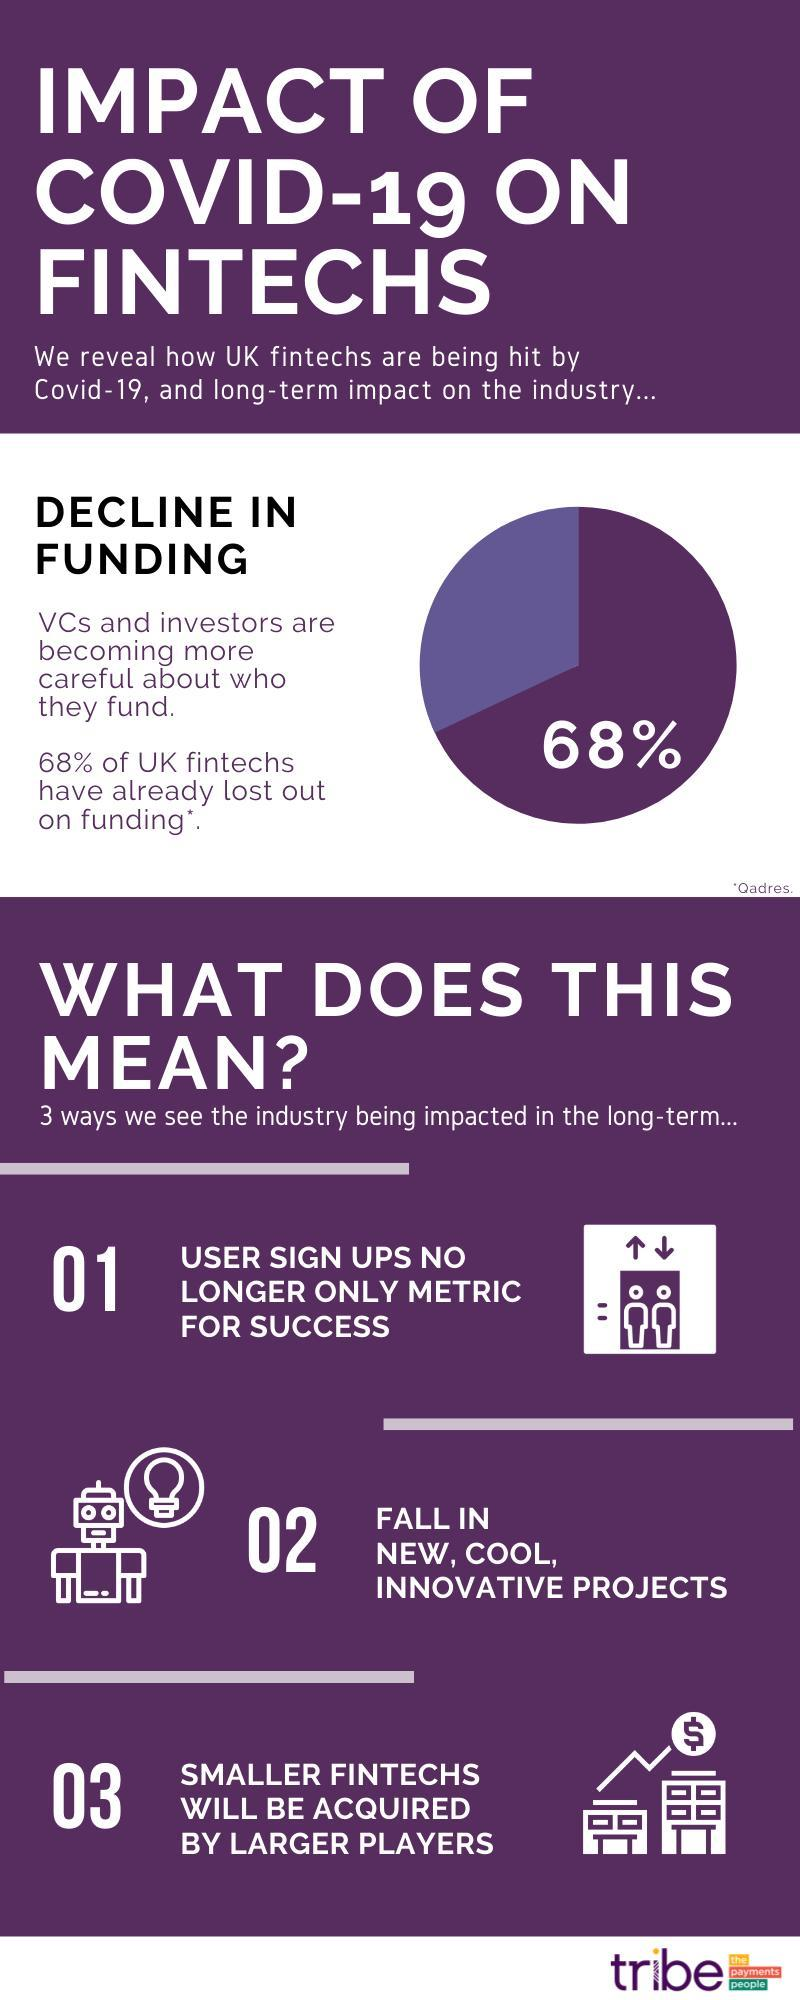What challenge does the robot and light bulb indicate
Answer the question with a short phrase. Fall in new, cool, innovative projects What challenge does the buildings and currency symbol indicate smaller fintechs will  be acquired by larger players What % of fintechs still have funding 32 